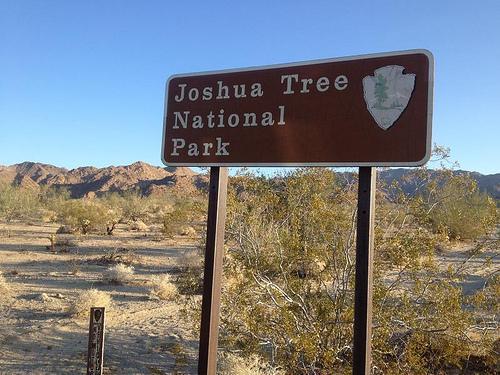How many signs are there?
Give a very brief answer. 1. 